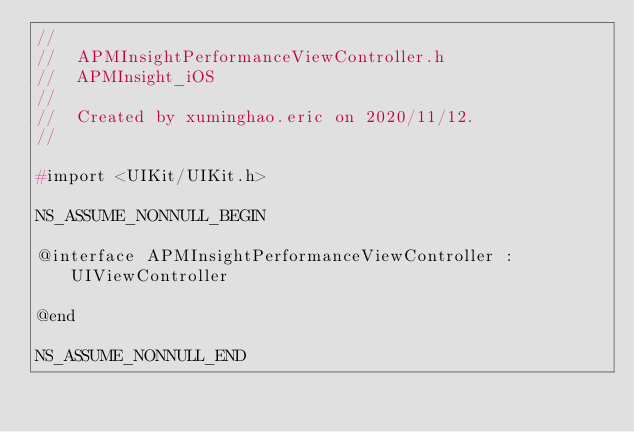Convert code to text. <code><loc_0><loc_0><loc_500><loc_500><_C_>//
//  APMInsightPerformanceViewController.h
//  APMInsight_iOS
//
//  Created by xuminghao.eric on 2020/11/12.
//

#import <UIKit/UIKit.h>

NS_ASSUME_NONNULL_BEGIN

@interface APMInsightPerformanceViewController : UIViewController

@end

NS_ASSUME_NONNULL_END
</code> 